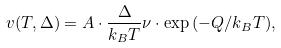<formula> <loc_0><loc_0><loc_500><loc_500>v ( T , \Delta ) = A \cdot \frac { \Delta } { k _ { B } T } \nu \cdot \exp { ( - Q / k _ { B } T ) } ,</formula> 